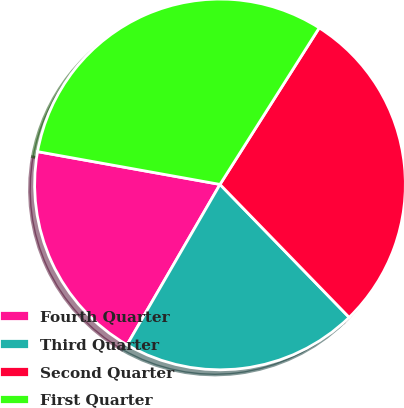<chart> <loc_0><loc_0><loc_500><loc_500><pie_chart><fcel>Fourth Quarter<fcel>Third Quarter<fcel>Second Quarter<fcel>First Quarter<nl><fcel>19.47%<fcel>20.63%<fcel>28.74%<fcel>31.16%<nl></chart> 